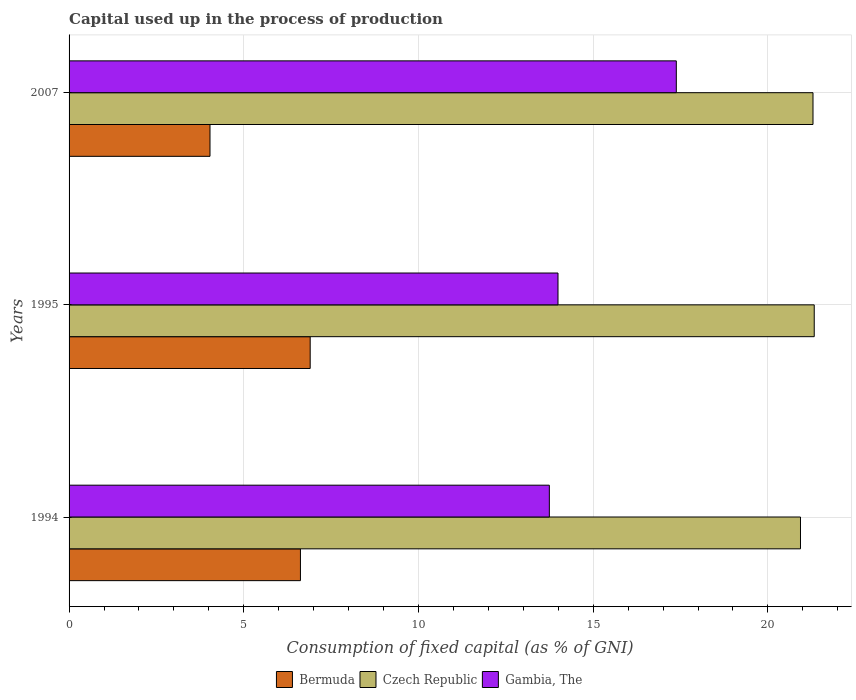Are the number of bars per tick equal to the number of legend labels?
Ensure brevity in your answer.  Yes. How many bars are there on the 3rd tick from the top?
Your response must be concise. 3. How many bars are there on the 2nd tick from the bottom?
Ensure brevity in your answer.  3. What is the label of the 2nd group of bars from the top?
Keep it short and to the point. 1995. In how many cases, is the number of bars for a given year not equal to the number of legend labels?
Keep it short and to the point. 0. What is the capital used up in the process of production in Gambia, The in 1994?
Your answer should be very brief. 13.74. Across all years, what is the maximum capital used up in the process of production in Gambia, The?
Make the answer very short. 17.38. Across all years, what is the minimum capital used up in the process of production in Gambia, The?
Your answer should be very brief. 13.74. In which year was the capital used up in the process of production in Czech Republic maximum?
Give a very brief answer. 1995. What is the total capital used up in the process of production in Bermuda in the graph?
Provide a succinct answer. 17.55. What is the difference between the capital used up in the process of production in Gambia, The in 1995 and that in 2007?
Provide a short and direct response. -3.39. What is the difference between the capital used up in the process of production in Bermuda in 1994 and the capital used up in the process of production in Czech Republic in 1995?
Your answer should be compact. -14.7. What is the average capital used up in the process of production in Czech Republic per year?
Your answer should be very brief. 21.18. In the year 1994, what is the difference between the capital used up in the process of production in Bermuda and capital used up in the process of production in Czech Republic?
Your answer should be very brief. -14.31. What is the ratio of the capital used up in the process of production in Gambia, The in 1994 to that in 1995?
Provide a short and direct response. 0.98. Is the capital used up in the process of production in Gambia, The in 1994 less than that in 2007?
Provide a succinct answer. Yes. What is the difference between the highest and the second highest capital used up in the process of production in Gambia, The?
Offer a very short reply. 3.39. What is the difference between the highest and the lowest capital used up in the process of production in Bermuda?
Your response must be concise. 2.87. Is the sum of the capital used up in the process of production in Gambia, The in 1994 and 2007 greater than the maximum capital used up in the process of production in Bermuda across all years?
Offer a terse response. Yes. What does the 1st bar from the top in 2007 represents?
Ensure brevity in your answer.  Gambia, The. What does the 3rd bar from the bottom in 1994 represents?
Your answer should be very brief. Gambia, The. Is it the case that in every year, the sum of the capital used up in the process of production in Bermuda and capital used up in the process of production in Czech Republic is greater than the capital used up in the process of production in Gambia, The?
Your answer should be compact. Yes. Are all the bars in the graph horizontal?
Make the answer very short. Yes. How many years are there in the graph?
Make the answer very short. 3. What is the difference between two consecutive major ticks on the X-axis?
Give a very brief answer. 5. Does the graph contain grids?
Offer a terse response. Yes. How many legend labels are there?
Offer a terse response. 3. What is the title of the graph?
Offer a very short reply. Capital used up in the process of production. Does "Venezuela" appear as one of the legend labels in the graph?
Your response must be concise. No. What is the label or title of the X-axis?
Your response must be concise. Consumption of fixed capital (as % of GNI). What is the label or title of the Y-axis?
Make the answer very short. Years. What is the Consumption of fixed capital (as % of GNI) in Bermuda in 1994?
Your response must be concise. 6.62. What is the Consumption of fixed capital (as % of GNI) of Czech Republic in 1994?
Offer a terse response. 20.93. What is the Consumption of fixed capital (as % of GNI) in Gambia, The in 1994?
Ensure brevity in your answer.  13.74. What is the Consumption of fixed capital (as % of GNI) of Bermuda in 1995?
Your answer should be compact. 6.9. What is the Consumption of fixed capital (as % of GNI) in Czech Republic in 1995?
Provide a succinct answer. 21.33. What is the Consumption of fixed capital (as % of GNI) of Gambia, The in 1995?
Your answer should be very brief. 13.99. What is the Consumption of fixed capital (as % of GNI) in Bermuda in 2007?
Make the answer very short. 4.03. What is the Consumption of fixed capital (as % of GNI) of Czech Republic in 2007?
Make the answer very short. 21.29. What is the Consumption of fixed capital (as % of GNI) in Gambia, The in 2007?
Provide a succinct answer. 17.38. Across all years, what is the maximum Consumption of fixed capital (as % of GNI) of Bermuda?
Ensure brevity in your answer.  6.9. Across all years, what is the maximum Consumption of fixed capital (as % of GNI) in Czech Republic?
Your answer should be very brief. 21.33. Across all years, what is the maximum Consumption of fixed capital (as % of GNI) in Gambia, The?
Your response must be concise. 17.38. Across all years, what is the minimum Consumption of fixed capital (as % of GNI) in Bermuda?
Keep it short and to the point. 4.03. Across all years, what is the minimum Consumption of fixed capital (as % of GNI) in Czech Republic?
Keep it short and to the point. 20.93. Across all years, what is the minimum Consumption of fixed capital (as % of GNI) of Gambia, The?
Your response must be concise. 13.74. What is the total Consumption of fixed capital (as % of GNI) in Bermuda in the graph?
Offer a terse response. 17.55. What is the total Consumption of fixed capital (as % of GNI) in Czech Republic in the graph?
Your answer should be very brief. 63.55. What is the total Consumption of fixed capital (as % of GNI) in Gambia, The in the graph?
Offer a very short reply. 45.11. What is the difference between the Consumption of fixed capital (as % of GNI) of Bermuda in 1994 and that in 1995?
Your answer should be compact. -0.28. What is the difference between the Consumption of fixed capital (as % of GNI) of Czech Republic in 1994 and that in 1995?
Make the answer very short. -0.39. What is the difference between the Consumption of fixed capital (as % of GNI) of Gambia, The in 1994 and that in 1995?
Your answer should be compact. -0.25. What is the difference between the Consumption of fixed capital (as % of GNI) in Bermuda in 1994 and that in 2007?
Provide a succinct answer. 2.59. What is the difference between the Consumption of fixed capital (as % of GNI) in Czech Republic in 1994 and that in 2007?
Your response must be concise. -0.36. What is the difference between the Consumption of fixed capital (as % of GNI) of Gambia, The in 1994 and that in 2007?
Ensure brevity in your answer.  -3.63. What is the difference between the Consumption of fixed capital (as % of GNI) in Bermuda in 1995 and that in 2007?
Your answer should be very brief. 2.87. What is the difference between the Consumption of fixed capital (as % of GNI) of Czech Republic in 1995 and that in 2007?
Offer a terse response. 0.04. What is the difference between the Consumption of fixed capital (as % of GNI) in Gambia, The in 1995 and that in 2007?
Give a very brief answer. -3.39. What is the difference between the Consumption of fixed capital (as % of GNI) in Bermuda in 1994 and the Consumption of fixed capital (as % of GNI) in Czech Republic in 1995?
Make the answer very short. -14.7. What is the difference between the Consumption of fixed capital (as % of GNI) in Bermuda in 1994 and the Consumption of fixed capital (as % of GNI) in Gambia, The in 1995?
Provide a succinct answer. -7.37. What is the difference between the Consumption of fixed capital (as % of GNI) of Czech Republic in 1994 and the Consumption of fixed capital (as % of GNI) of Gambia, The in 1995?
Your answer should be compact. 6.94. What is the difference between the Consumption of fixed capital (as % of GNI) of Bermuda in 1994 and the Consumption of fixed capital (as % of GNI) of Czech Republic in 2007?
Your answer should be compact. -14.67. What is the difference between the Consumption of fixed capital (as % of GNI) in Bermuda in 1994 and the Consumption of fixed capital (as % of GNI) in Gambia, The in 2007?
Offer a very short reply. -10.76. What is the difference between the Consumption of fixed capital (as % of GNI) of Czech Republic in 1994 and the Consumption of fixed capital (as % of GNI) of Gambia, The in 2007?
Your answer should be compact. 3.55. What is the difference between the Consumption of fixed capital (as % of GNI) in Bermuda in 1995 and the Consumption of fixed capital (as % of GNI) in Czech Republic in 2007?
Your response must be concise. -14.39. What is the difference between the Consumption of fixed capital (as % of GNI) of Bermuda in 1995 and the Consumption of fixed capital (as % of GNI) of Gambia, The in 2007?
Offer a terse response. -10.48. What is the difference between the Consumption of fixed capital (as % of GNI) in Czech Republic in 1995 and the Consumption of fixed capital (as % of GNI) in Gambia, The in 2007?
Offer a terse response. 3.95. What is the average Consumption of fixed capital (as % of GNI) of Bermuda per year?
Keep it short and to the point. 5.85. What is the average Consumption of fixed capital (as % of GNI) of Czech Republic per year?
Provide a succinct answer. 21.18. What is the average Consumption of fixed capital (as % of GNI) in Gambia, The per year?
Your answer should be compact. 15.04. In the year 1994, what is the difference between the Consumption of fixed capital (as % of GNI) of Bermuda and Consumption of fixed capital (as % of GNI) of Czech Republic?
Your answer should be very brief. -14.31. In the year 1994, what is the difference between the Consumption of fixed capital (as % of GNI) of Bermuda and Consumption of fixed capital (as % of GNI) of Gambia, The?
Keep it short and to the point. -7.12. In the year 1994, what is the difference between the Consumption of fixed capital (as % of GNI) of Czech Republic and Consumption of fixed capital (as % of GNI) of Gambia, The?
Keep it short and to the point. 7.19. In the year 1995, what is the difference between the Consumption of fixed capital (as % of GNI) of Bermuda and Consumption of fixed capital (as % of GNI) of Czech Republic?
Your response must be concise. -14.43. In the year 1995, what is the difference between the Consumption of fixed capital (as % of GNI) of Bermuda and Consumption of fixed capital (as % of GNI) of Gambia, The?
Keep it short and to the point. -7.09. In the year 1995, what is the difference between the Consumption of fixed capital (as % of GNI) in Czech Republic and Consumption of fixed capital (as % of GNI) in Gambia, The?
Offer a very short reply. 7.33. In the year 2007, what is the difference between the Consumption of fixed capital (as % of GNI) of Bermuda and Consumption of fixed capital (as % of GNI) of Czech Republic?
Give a very brief answer. -17.26. In the year 2007, what is the difference between the Consumption of fixed capital (as % of GNI) of Bermuda and Consumption of fixed capital (as % of GNI) of Gambia, The?
Keep it short and to the point. -13.34. In the year 2007, what is the difference between the Consumption of fixed capital (as % of GNI) of Czech Republic and Consumption of fixed capital (as % of GNI) of Gambia, The?
Your answer should be compact. 3.91. What is the ratio of the Consumption of fixed capital (as % of GNI) of Bermuda in 1994 to that in 1995?
Offer a terse response. 0.96. What is the ratio of the Consumption of fixed capital (as % of GNI) of Czech Republic in 1994 to that in 1995?
Provide a succinct answer. 0.98. What is the ratio of the Consumption of fixed capital (as % of GNI) of Gambia, The in 1994 to that in 1995?
Ensure brevity in your answer.  0.98. What is the ratio of the Consumption of fixed capital (as % of GNI) in Bermuda in 1994 to that in 2007?
Ensure brevity in your answer.  1.64. What is the ratio of the Consumption of fixed capital (as % of GNI) of Czech Republic in 1994 to that in 2007?
Keep it short and to the point. 0.98. What is the ratio of the Consumption of fixed capital (as % of GNI) in Gambia, The in 1994 to that in 2007?
Offer a very short reply. 0.79. What is the ratio of the Consumption of fixed capital (as % of GNI) of Bermuda in 1995 to that in 2007?
Your answer should be very brief. 1.71. What is the ratio of the Consumption of fixed capital (as % of GNI) of Gambia, The in 1995 to that in 2007?
Keep it short and to the point. 0.81. What is the difference between the highest and the second highest Consumption of fixed capital (as % of GNI) in Bermuda?
Ensure brevity in your answer.  0.28. What is the difference between the highest and the second highest Consumption of fixed capital (as % of GNI) of Czech Republic?
Offer a terse response. 0.04. What is the difference between the highest and the second highest Consumption of fixed capital (as % of GNI) in Gambia, The?
Your response must be concise. 3.39. What is the difference between the highest and the lowest Consumption of fixed capital (as % of GNI) of Bermuda?
Give a very brief answer. 2.87. What is the difference between the highest and the lowest Consumption of fixed capital (as % of GNI) of Czech Republic?
Give a very brief answer. 0.39. What is the difference between the highest and the lowest Consumption of fixed capital (as % of GNI) of Gambia, The?
Offer a very short reply. 3.63. 